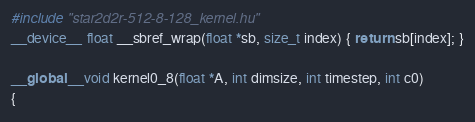Convert code to text. <code><loc_0><loc_0><loc_500><loc_500><_Cuda_>#include "star2d2r-512-8-128_kernel.hu"
__device__ float __sbref_wrap(float *sb, size_t index) { return sb[index]; }

__global__ void kernel0_8(float *A, int dimsize, int timestep, int c0)
{</code> 